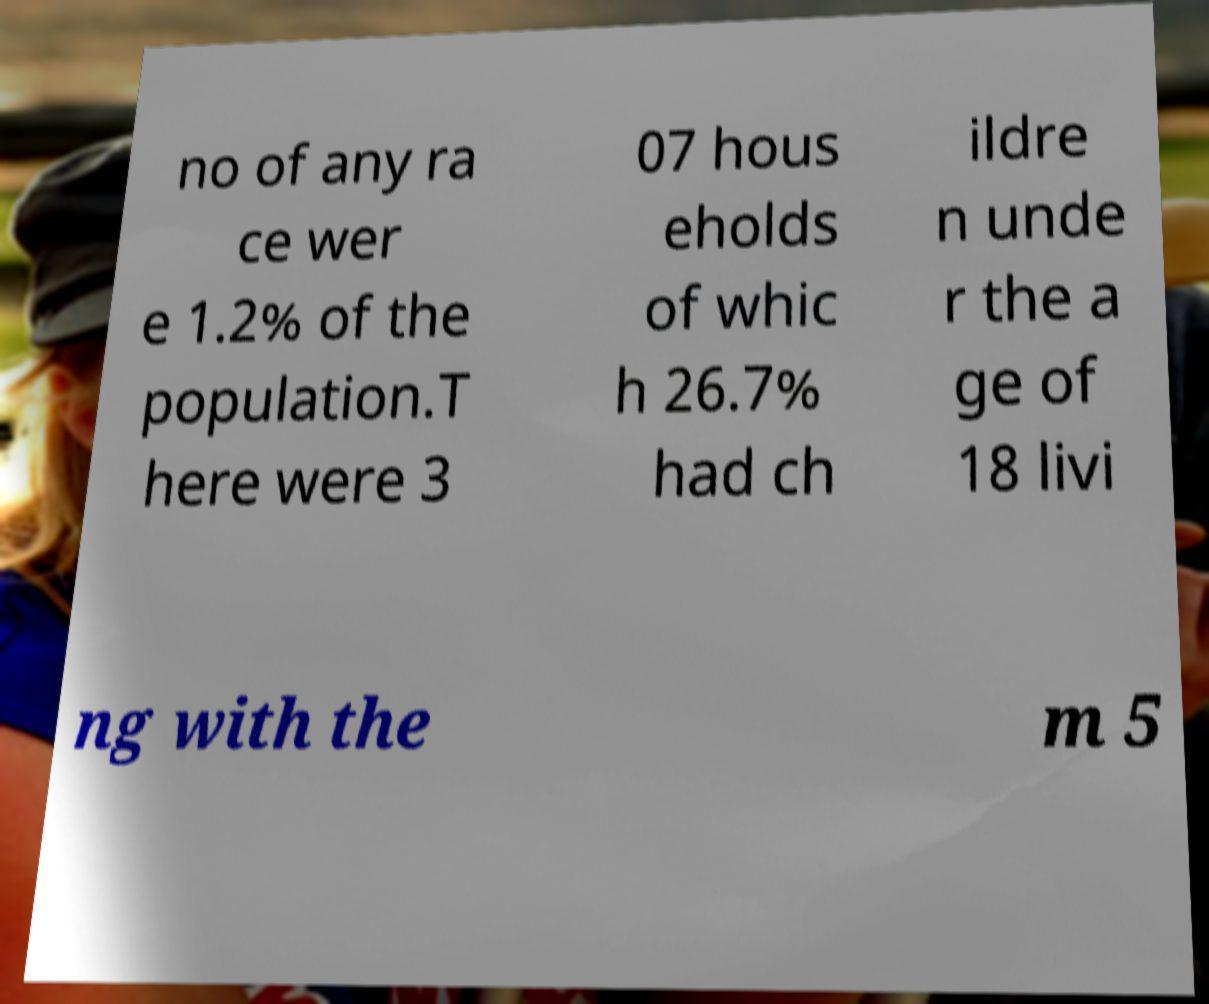For documentation purposes, I need the text within this image transcribed. Could you provide that? no of any ra ce wer e 1.2% of the population.T here were 3 07 hous eholds of whic h 26.7% had ch ildre n unde r the a ge of 18 livi ng with the m 5 